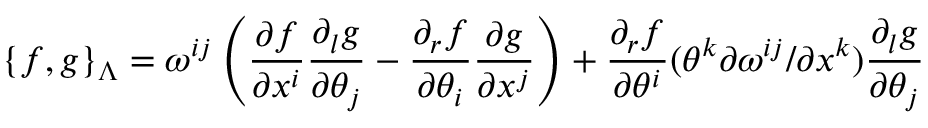<formula> <loc_0><loc_0><loc_500><loc_500>\{ f , g \} _ { \Lambda } = \omega ^ { i j } \left ( \frac { \partial f } { \partial x ^ { i } } \frac { \partial _ { l } g } { \partial \theta _ { j } } - \frac { \partial _ { r } f } { \partial \theta _ { i } } \frac { \partial g } { \partial x ^ { j } } \right ) + \frac { \partial _ { r } f } { \partial \theta ^ { i } } ( \theta ^ { k } { \partial \omega ^ { i j } } / { \partial x ^ { k } } ) \frac { \partial _ { l } g } { \partial \theta _ { j } }</formula> 